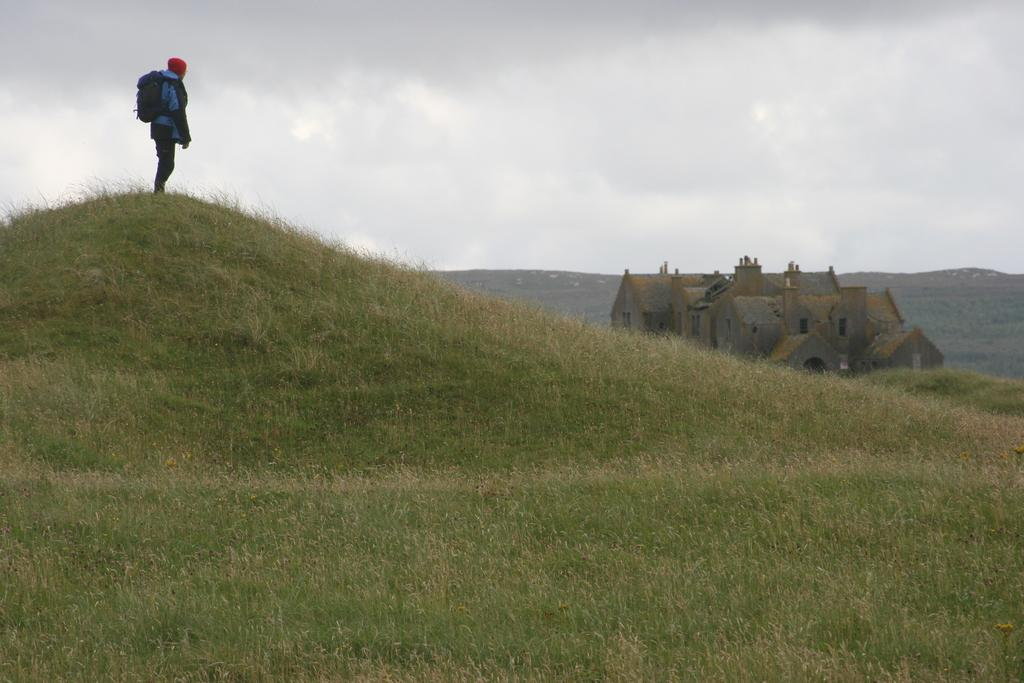What can be seen in the image? There is a person in the image. What is the person wearing? The person is wearing a backpack. Where is the person standing? The person is standing on a hill. What type of vegetation is on the hill? There is grass on the hill. What other structures are visible in the image? There is a house in the image. What natural features can be seen in the background? There are mountains visible in the image. What type of apparatus is the person using to climb the hill? There is no apparatus visible in the image; the person is simply standing on the hill. Can you tell me how many grandmothers are present in the image? There is no mention of a grandmother in the image; it features a person standing on a hill. 